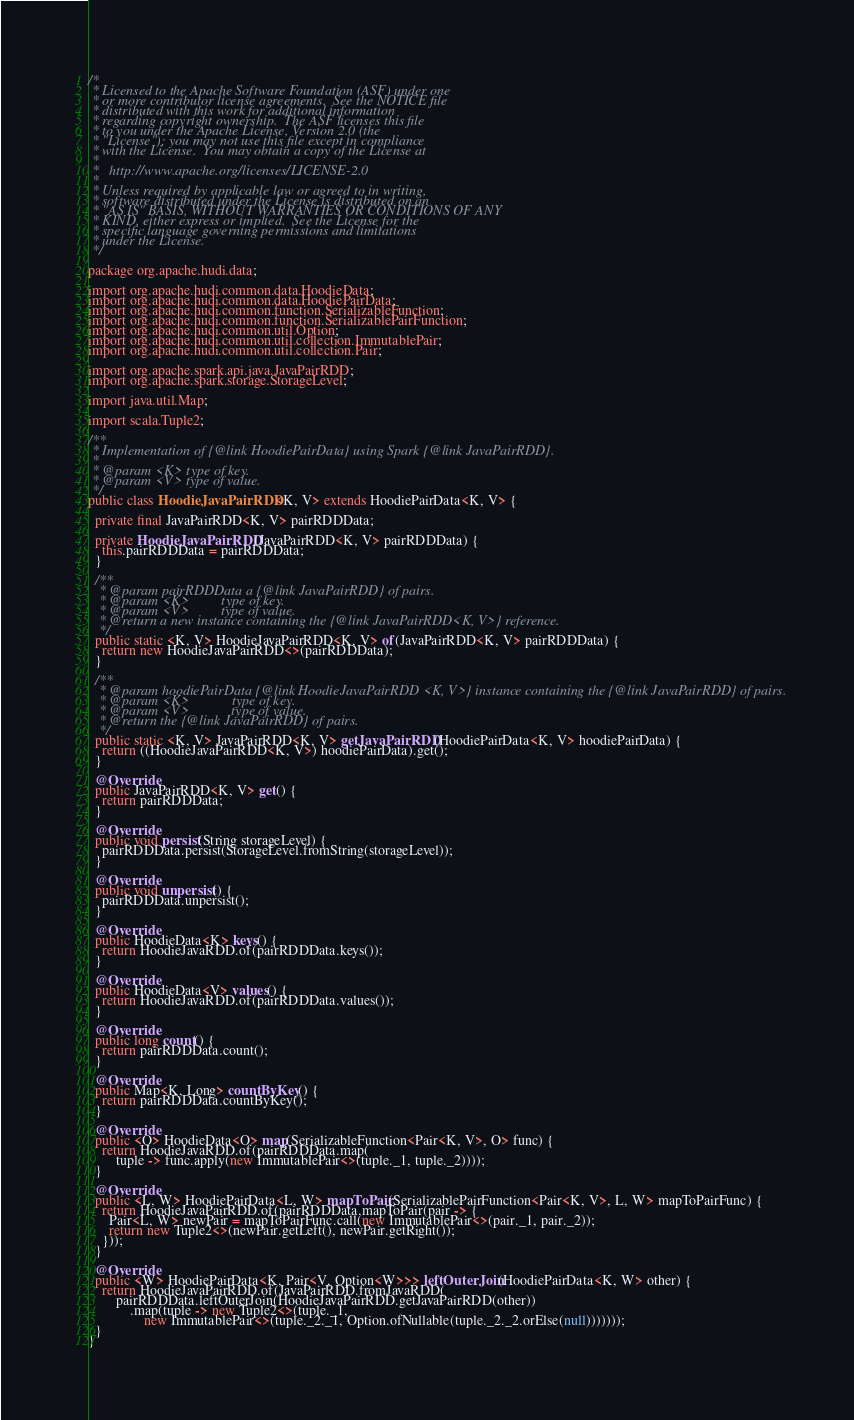<code> <loc_0><loc_0><loc_500><loc_500><_Java_>/*
 * Licensed to the Apache Software Foundation (ASF) under one
 * or more contributor license agreements.  See the NOTICE file
 * distributed with this work for additional information
 * regarding copyright ownership.  The ASF licenses this file
 * to you under the Apache License, Version 2.0 (the
 * "License"); you may not use this file except in compliance
 * with the License.  You may obtain a copy of the License at
 *
 *   http://www.apache.org/licenses/LICENSE-2.0
 *
 * Unless required by applicable law or agreed to in writing,
 * software distributed under the License is distributed on an
 * "AS IS" BASIS, WITHOUT WARRANTIES OR CONDITIONS OF ANY
 * KIND, either express or implied.  See the License for the
 * specific language governing permissions and limitations
 * under the License.
 */

package org.apache.hudi.data;

import org.apache.hudi.common.data.HoodieData;
import org.apache.hudi.common.data.HoodiePairData;
import org.apache.hudi.common.function.SerializableFunction;
import org.apache.hudi.common.function.SerializablePairFunction;
import org.apache.hudi.common.util.Option;
import org.apache.hudi.common.util.collection.ImmutablePair;
import org.apache.hudi.common.util.collection.Pair;

import org.apache.spark.api.java.JavaPairRDD;
import org.apache.spark.storage.StorageLevel;

import java.util.Map;

import scala.Tuple2;

/**
 * Implementation of {@link HoodiePairData} using Spark {@link JavaPairRDD}.
 *
 * @param <K> type of key.
 * @param <V> type of value.
 */
public class HoodieJavaPairRDD<K, V> extends HoodiePairData<K, V> {

  private final JavaPairRDD<K, V> pairRDDData;

  private HoodieJavaPairRDD(JavaPairRDD<K, V> pairRDDData) {
    this.pairRDDData = pairRDDData;
  }

  /**
   * @param pairRDDData a {@link JavaPairRDD} of pairs.
   * @param <K>         type of key.
   * @param <V>         type of value.
   * @return a new instance containing the {@link JavaPairRDD<K, V>} reference.
   */
  public static <K, V> HoodieJavaPairRDD<K, V> of(JavaPairRDD<K, V> pairRDDData) {
    return new HoodieJavaPairRDD<>(pairRDDData);
  }

  /**
   * @param hoodiePairData {@link HoodieJavaPairRDD <K, V>} instance containing the {@link JavaPairRDD} of pairs.
   * @param <K>            type of key.
   * @param <V>            type of value.
   * @return the {@link JavaPairRDD} of pairs.
   */
  public static <K, V> JavaPairRDD<K, V> getJavaPairRDD(HoodiePairData<K, V> hoodiePairData) {
    return ((HoodieJavaPairRDD<K, V>) hoodiePairData).get();
  }

  @Override
  public JavaPairRDD<K, V> get() {
    return pairRDDData;
  }

  @Override
  public void persist(String storageLevel) {
    pairRDDData.persist(StorageLevel.fromString(storageLevel));
  }

  @Override
  public void unpersist() {
    pairRDDData.unpersist();
  }

  @Override
  public HoodieData<K> keys() {
    return HoodieJavaRDD.of(pairRDDData.keys());
  }

  @Override
  public HoodieData<V> values() {
    return HoodieJavaRDD.of(pairRDDData.values());
  }

  @Override
  public long count() {
    return pairRDDData.count();
  }

  @Override
  public Map<K, Long> countByKey() {
    return pairRDDData.countByKey();
  }

  @Override
  public <O> HoodieData<O> map(SerializableFunction<Pair<K, V>, O> func) {
    return HoodieJavaRDD.of(pairRDDData.map(
        tuple -> func.apply(new ImmutablePair<>(tuple._1, tuple._2))));
  }

  @Override
  public <L, W> HoodiePairData<L, W> mapToPair(SerializablePairFunction<Pair<K, V>, L, W> mapToPairFunc) {
    return HoodieJavaPairRDD.of(pairRDDData.mapToPair(pair -> {
      Pair<L, W> newPair = mapToPairFunc.call(new ImmutablePair<>(pair._1, pair._2));
      return new Tuple2<>(newPair.getLeft(), newPair.getRight());
    }));
  }

  @Override
  public <W> HoodiePairData<K, Pair<V, Option<W>>> leftOuterJoin(HoodiePairData<K, W> other) {
    return HoodieJavaPairRDD.of(JavaPairRDD.fromJavaRDD(
        pairRDDData.leftOuterJoin(HoodieJavaPairRDD.getJavaPairRDD(other))
            .map(tuple -> new Tuple2<>(tuple._1,
                new ImmutablePair<>(tuple._2._1, Option.ofNullable(tuple._2._2.orElse(null)))))));
  }
}
</code> 